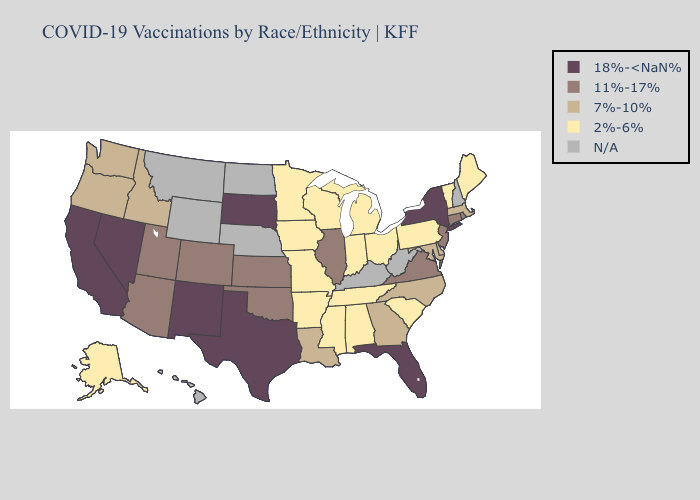Which states have the highest value in the USA?
Give a very brief answer. California, Florida, Nevada, New Mexico, New York, South Dakota, Texas. What is the highest value in the West ?
Give a very brief answer. 18%-<NaN%. Does Colorado have the highest value in the USA?
Give a very brief answer. No. Name the states that have a value in the range 11%-17%?
Keep it brief. Arizona, Colorado, Connecticut, Illinois, Kansas, New Jersey, Oklahoma, Rhode Island, Utah, Virginia. Among the states that border Oklahoma , does Texas have the highest value?
Quick response, please. Yes. Name the states that have a value in the range 18%-<NaN%?
Keep it brief. California, Florida, Nevada, New Mexico, New York, South Dakota, Texas. What is the highest value in states that border Nevada?
Give a very brief answer. 18%-<NaN%. What is the value of West Virginia?
Give a very brief answer. N/A. Which states have the highest value in the USA?
Write a very short answer. California, Florida, Nevada, New Mexico, New York, South Dakota, Texas. What is the lowest value in the Northeast?
Answer briefly. 2%-6%. What is the lowest value in the Northeast?
Answer briefly. 2%-6%. 